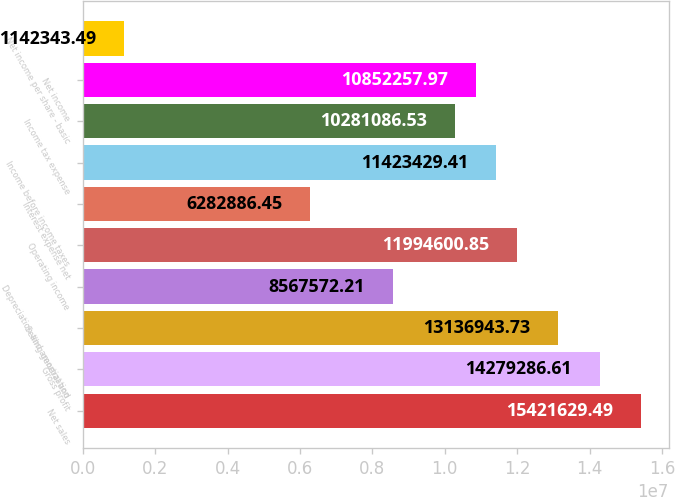Convert chart. <chart><loc_0><loc_0><loc_500><loc_500><bar_chart><fcel>Net sales<fcel>Gross profit<fcel>Selling general and<fcel>Depreciation and amortization<fcel>Operating income<fcel>Interest expense net<fcel>Income before income taxes<fcel>Income tax expense<fcel>Net income<fcel>Net income per share - basic<nl><fcel>1.54216e+07<fcel>1.42793e+07<fcel>1.31369e+07<fcel>8.56757e+06<fcel>1.19946e+07<fcel>6.28289e+06<fcel>1.14234e+07<fcel>1.02811e+07<fcel>1.08523e+07<fcel>1.14234e+06<nl></chart> 